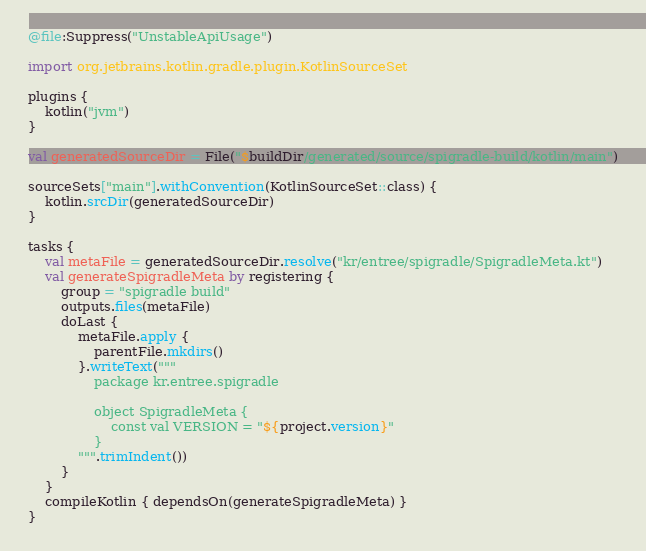Convert code to text. <code><loc_0><loc_0><loc_500><loc_500><_Kotlin_>@file:Suppress("UnstableApiUsage")

import org.jetbrains.kotlin.gradle.plugin.KotlinSourceSet

plugins {
    kotlin("jvm")
}

val generatedSourceDir = File("$buildDir/generated/source/spigradle-build/kotlin/main")

sourceSets["main"].withConvention(KotlinSourceSet::class) {
    kotlin.srcDir(generatedSourceDir)
}

tasks {
    val metaFile = generatedSourceDir.resolve("kr/entree/spigradle/SpigradleMeta.kt")
    val generateSpigradleMeta by registering {
        group = "spigradle build"
        outputs.files(metaFile)
        doLast {
            metaFile.apply {
                parentFile.mkdirs()
            }.writeText("""
                package kr.entree.spigradle

                object SpigradleMeta {
                    const val VERSION = "${project.version}"
                }
            """.trimIndent())
        }
    }
    compileKotlin { dependsOn(generateSpigradleMeta) }
}</code> 